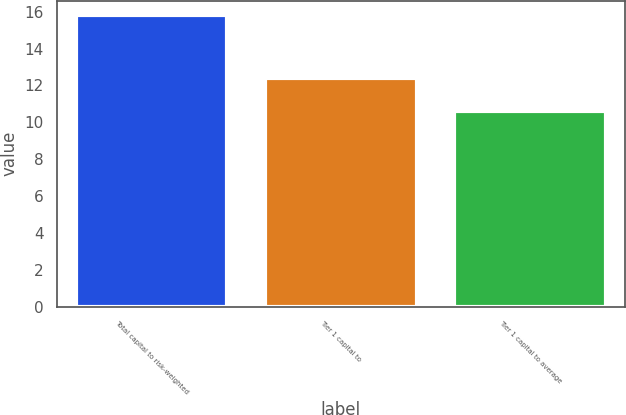Convert chart. <chart><loc_0><loc_0><loc_500><loc_500><bar_chart><fcel>Total capital to risk-weighted<fcel>Tier 1 capital to<fcel>Tier 1 capital to average<nl><fcel>15.8<fcel>12.4<fcel>10.6<nl></chart> 